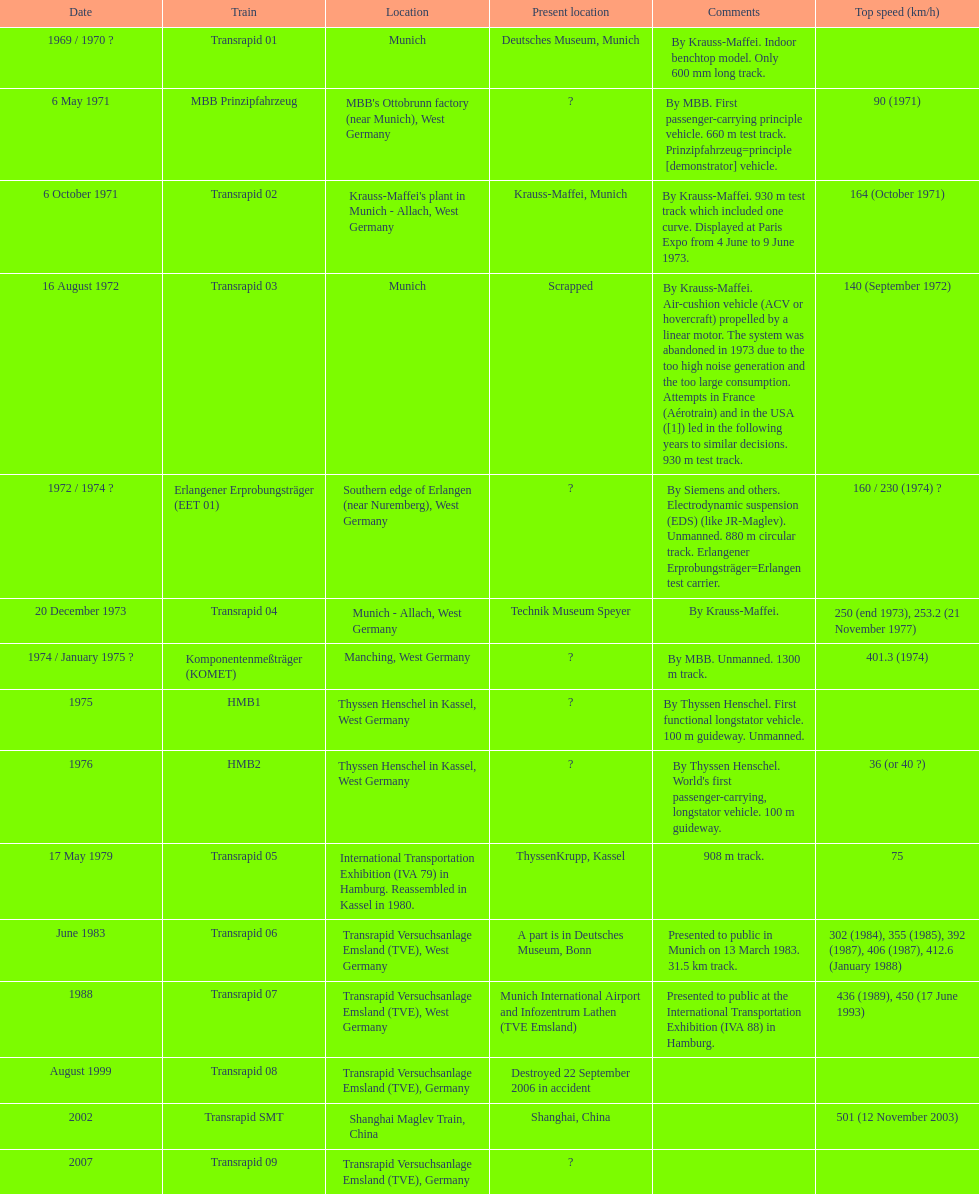How many versions have been scrapped? 1. 